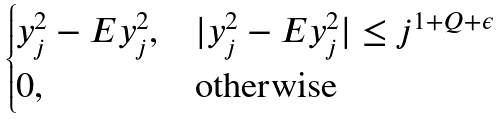<formula> <loc_0><loc_0><loc_500><loc_500>\begin{cases} y _ { j } ^ { 2 } - E y _ { j } ^ { 2 } , & | y _ { j } ^ { 2 } - E y _ { j } ^ { 2 } | \leq j ^ { 1 + Q + \epsilon } \\ 0 , & \text {otherwise} \end{cases}</formula> 